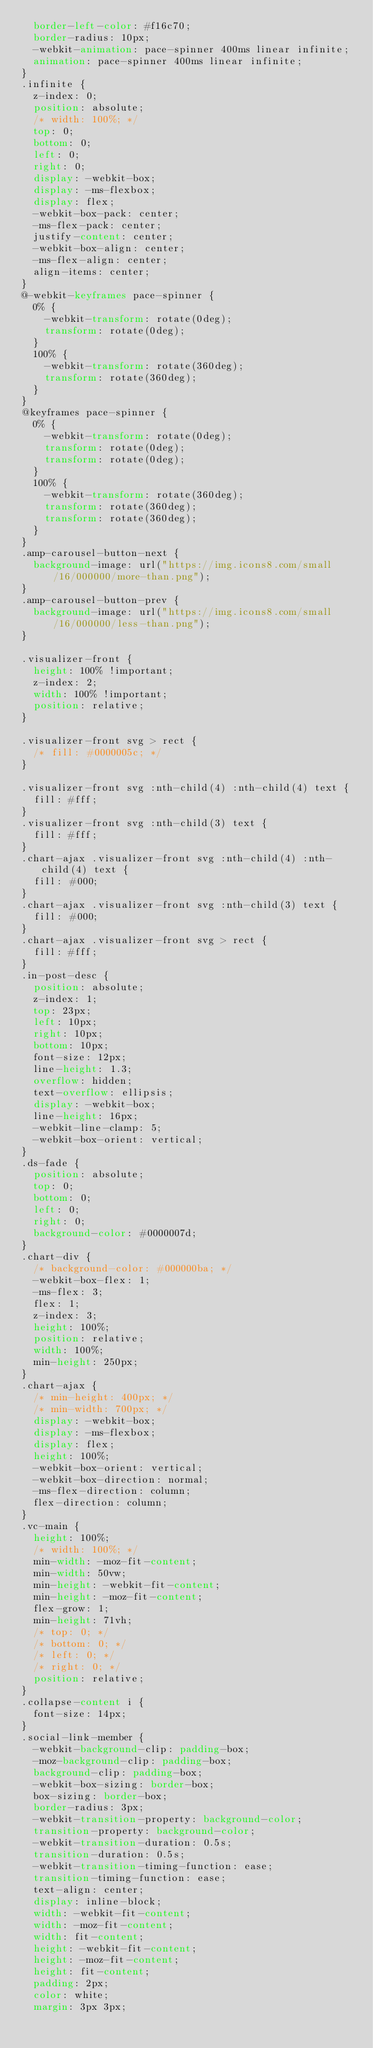Convert code to text. <code><loc_0><loc_0><loc_500><loc_500><_CSS_>  border-left-color: #f16c70;
  border-radius: 10px;
  -webkit-animation: pace-spinner 400ms linear infinite;
  animation: pace-spinner 400ms linear infinite;
}
.infinite {
  z-index: 0;
  position: absolute;
  /* width: 100%; */
  top: 0;
  bottom: 0;
  left: 0;
  right: 0;
  display: -webkit-box;
  display: -ms-flexbox;
  display: flex;
  -webkit-box-pack: center;
  -ms-flex-pack: center;
  justify-content: center;
  -webkit-box-align: center;
  -ms-flex-align: center;
  align-items: center;
}
@-webkit-keyframes pace-spinner {
  0% {
    -webkit-transform: rotate(0deg);
    transform: rotate(0deg);
  }
  100% {
    -webkit-transform: rotate(360deg);
    transform: rotate(360deg);
  }
}
@keyframes pace-spinner {
  0% {
    -webkit-transform: rotate(0deg);
    transform: rotate(0deg);
    transform: rotate(0deg);
  }
  100% {
    -webkit-transform: rotate(360deg);
    transform: rotate(360deg);
    transform: rotate(360deg);
  }
}
.amp-carousel-button-next {
  background-image: url("https://img.icons8.com/small/16/000000/more-than.png");
}
.amp-carousel-button-prev {
  background-image: url("https://img.icons8.com/small/16/000000/less-than.png");
}

.visualizer-front {
  height: 100% !important;
  z-index: 2;
  width: 100% !important;
  position: relative;
}

.visualizer-front svg > rect {
  /* fill: #0000005c; */
}

.visualizer-front svg :nth-child(4) :nth-child(4) text {
  fill: #fff;
}
.visualizer-front svg :nth-child(3) text {
  fill: #fff;
}
.chart-ajax .visualizer-front svg :nth-child(4) :nth-child(4) text {
  fill: #000;
}
.chart-ajax .visualizer-front svg :nth-child(3) text {
  fill: #000;
}
.chart-ajax .visualizer-front svg > rect {
  fill: #fff;
}
.in-post-desc {
  position: absolute;
  z-index: 1;
  top: 23px;
  left: 10px;
  right: 10px;
  bottom: 10px;
  font-size: 12px;
  line-height: 1.3;
  overflow: hidden;
  text-overflow: ellipsis;
  display: -webkit-box;
  line-height: 16px;
  -webkit-line-clamp: 5;
  -webkit-box-orient: vertical;
}
.ds-fade {
  position: absolute;
  top: 0;
  bottom: 0;
  left: 0;
  right: 0;
  background-color: #0000007d;
}
.chart-div {
  /* background-color: #000000ba; */
  -webkit-box-flex: 1;
  -ms-flex: 3;
  flex: 1;
  z-index: 3;
  height: 100%;
  position: relative;
  width: 100%;
  min-height: 250px;
}
.chart-ajax {
  /* min-height: 400px; */
  /* min-width: 700px; */
  display: -webkit-box;
  display: -ms-flexbox;
  display: flex;
  height: 100%;
  -webkit-box-orient: vertical;
  -webkit-box-direction: normal;
  -ms-flex-direction: column;
  flex-direction: column;
}
.vc-main {
  height: 100%;
  /* width: 100%; */
  min-width: -moz-fit-content;
  min-width: 50vw;
  min-height: -webkit-fit-content;
  min-height: -moz-fit-content;
  flex-grow: 1;
  min-height: 71vh;
  /* top: 0; */
  /* bottom: 0; */
  /* left: 0; */
  /* right: 0; */
  position: relative;
}
.collapse-content i {
  font-size: 14px;
}
.social-link-member {
  -webkit-background-clip: padding-box;
  -moz-background-clip: padding-box;
  background-clip: padding-box;
  -webkit-box-sizing: border-box;
  box-sizing: border-box;
  border-radius: 3px;
  -webkit-transition-property: background-color;
  transition-property: background-color;
  -webkit-transition-duration: 0.5s;
  transition-duration: 0.5s;
  -webkit-transition-timing-function: ease;
  transition-timing-function: ease;
  text-align: center;
  display: inline-block;
  width: -webkit-fit-content;
  width: -moz-fit-content;
  width: fit-content;
  height: -webkit-fit-content;
  height: -moz-fit-content;
  height: fit-content;
  padding: 2px;
  color: white;
  margin: 3px 3px;</code> 